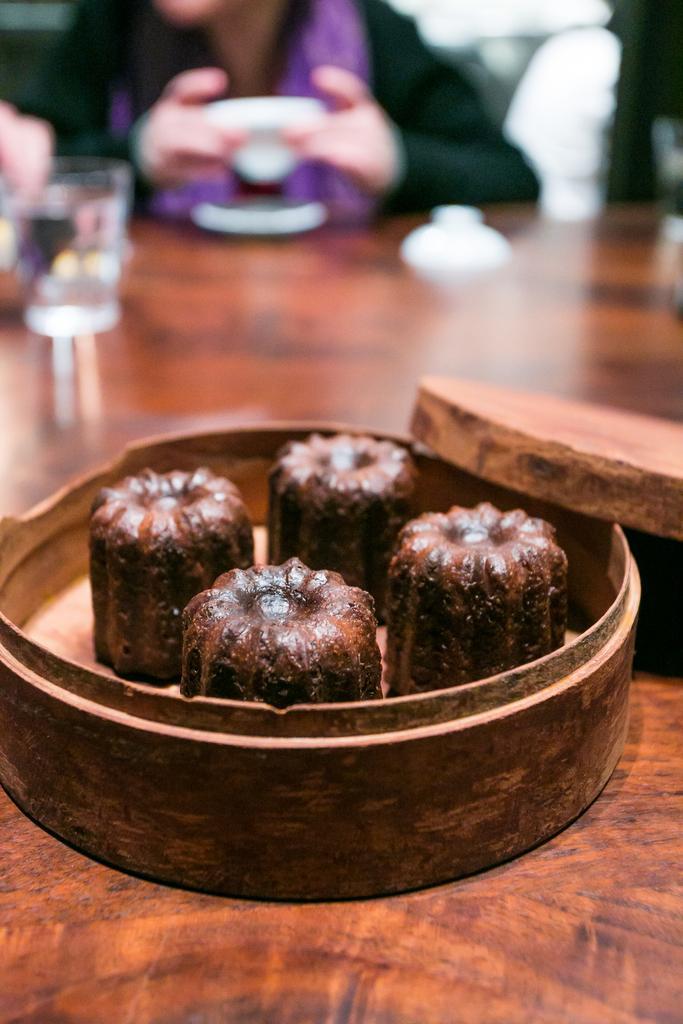Can you describe this image briefly? This image consists of a table. On that there are boxes. In that there are some eatables. There is a person at the top. 